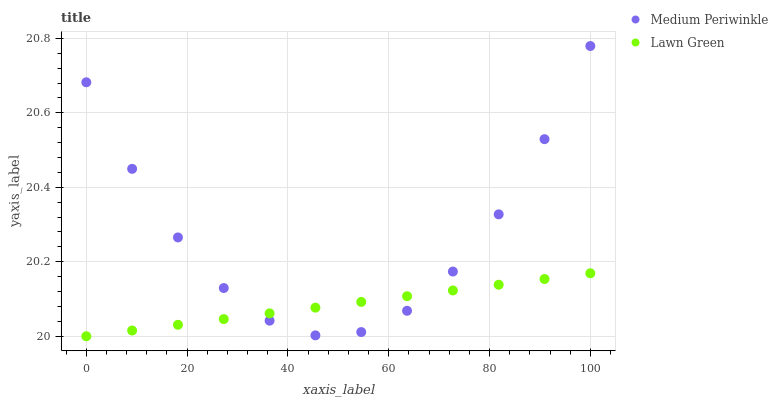Does Lawn Green have the minimum area under the curve?
Answer yes or no. Yes. Does Medium Periwinkle have the maximum area under the curve?
Answer yes or no. Yes. Does Medium Periwinkle have the minimum area under the curve?
Answer yes or no. No. Is Lawn Green the smoothest?
Answer yes or no. Yes. Is Medium Periwinkle the roughest?
Answer yes or no. Yes. Is Medium Periwinkle the smoothest?
Answer yes or no. No. Does Lawn Green have the lowest value?
Answer yes or no. Yes. Does Medium Periwinkle have the lowest value?
Answer yes or no. No. Does Medium Periwinkle have the highest value?
Answer yes or no. Yes. Does Lawn Green intersect Medium Periwinkle?
Answer yes or no. Yes. Is Lawn Green less than Medium Periwinkle?
Answer yes or no. No. Is Lawn Green greater than Medium Periwinkle?
Answer yes or no. No. 